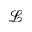<formula> <loc_0><loc_0><loc_500><loc_500>\mathcal { L }</formula> 